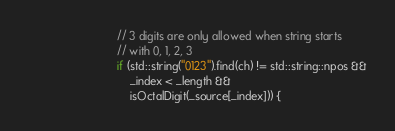<code> <loc_0><loc_0><loc_500><loc_500><_ObjectiveC_>                            // 3 digits are only allowed when string starts
                            // with 0, 1, 2, 3
                            if (std::string("0123").find(ch) != std::string::npos &&
                                _index < _length &&
                                isOctalDigit(_source[_index])) {</code> 